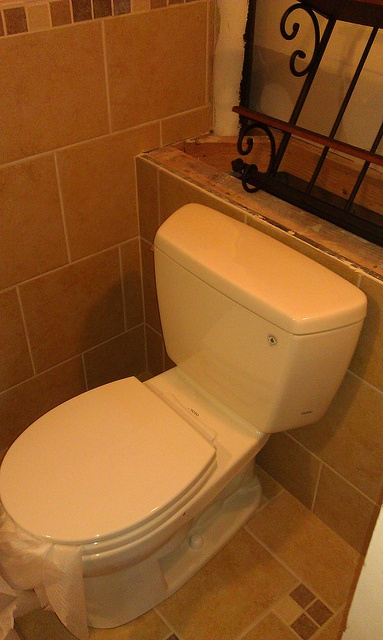Describe the objects in this image and their specific colors. I can see a toilet in red, orange, olive, and maroon tones in this image. 